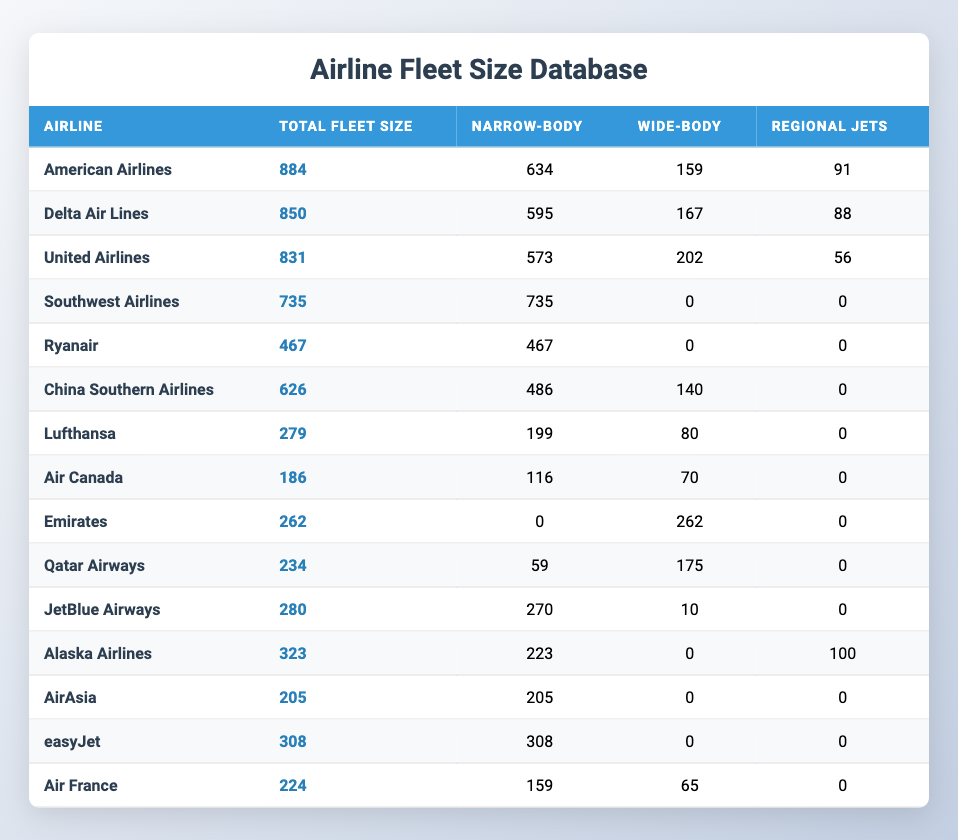What is the total fleet size of American Airlines? The total fleet size of American Airlines is directly listed in the table under the "Total Fleet Size" column, which shows the value of 884 for American Airlines.
Answer: 884 What is the number of wide-body aircraft for Delta Air Lines? The table indicates that the number of wide-body aircraft for Delta Air Lines can be found in the "Wide-body" column, which shows the value of 167 for the airline.
Answer: 167 Which airline has the largest total fleet size? To determine which airline has the largest total fleet size, we can compare the values in the "Total Fleet Size" column. American Airlines has the highest value of 884, making it the largest in fleet size.
Answer: American Airlines How many Regional Jets does United Airlines have? Looking at the row for United Airlines, the "Regional Jets" column indicates that United Airlines has 56 Regional Jets.
Answer: 56 What is the average total fleet size of all airlines listed? To find the average total fleet size, we first sum all the total fleet sizes (884 + 850 + 831 + 735 + 467 + 626 + 279 + 186 + 262 + 234 + 280 + 323 + 205 + 308 + 224 = 6,420) and then divide by the number of airlines (15): 6,420 / 15 = 428. Hence, the average total fleet size is 428.
Answer: 428 Is it true that Southwest Airlines has no wide-body aircraft? The table shows that the number of wide-body aircraft for Southwest Airlines is listed as 0 in the "Wide-body" column. This confirms that it is true that they do not operate any wide-body aircraft.
Answer: Yes How many more narrow-body aircraft does Ryanair have compared to Air France? To find the difference in narrow-body aircraft between Ryanair and Air France, we subtract the number for Air France (159) from Ryanair (467): 467 - 159 = 308. Therefore, Ryanair has 308 more narrow-body aircraft than Air France.
Answer: 308 Which airline has a total fleet size under 300? By analyzing the "Total Fleet Size" column, we see that Lufthansa (279) and Air Canada (186) are the only airlines with a total fleet size under 300.
Answer: Lufthansa and Air Canada What is the total number of regional jets across all airlines? To find the total number of regional jets, we must sum the values from the "Regional Jets" column: (91 + 88 + 56 + 0 + 0 + 0 + 0 + 0 + 0 + 0 + 0 + 100 + 0 + 0 + 0) = 335. Thus, the total number of regional jets across all airlines is 335.
Answer: 335 How many airlines have zero wide-body aircraft? Reviewing the "Wide-body" column, we see that Southwest Airlines, Ryanair, China Southern Airlines, Lufthansa, Air Canada, Emirates, JetBlue Airways, and AirAsia have zero wide-body aircraft. That amounts to 8 airlines.
Answer: 8 